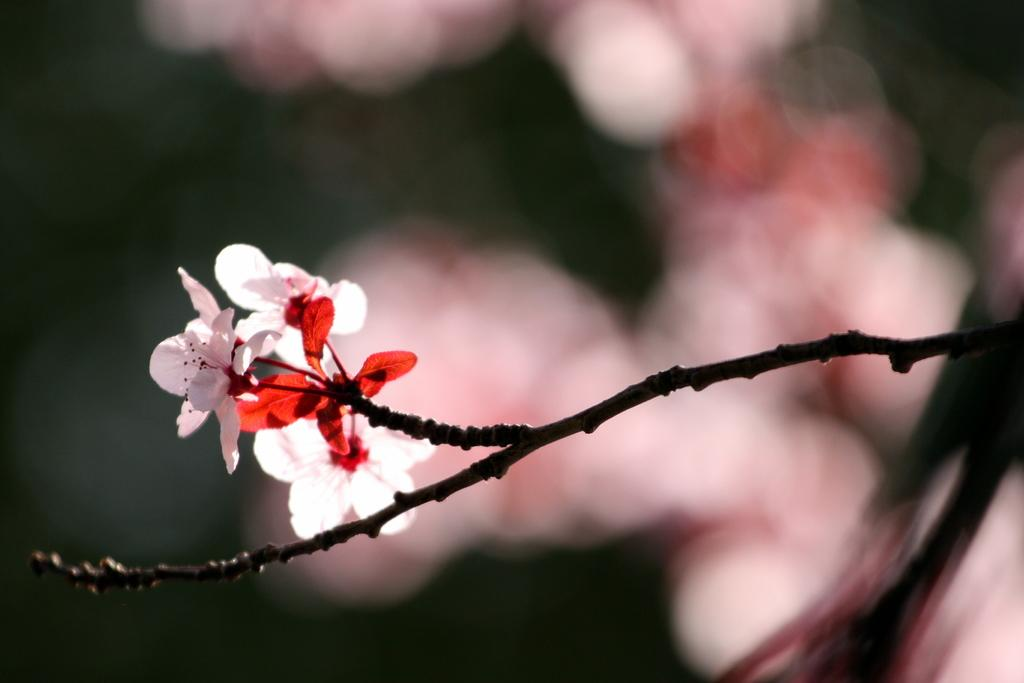What type of plant can be seen on the branch in the image? There are flowers on the branch of a tree in the image. How many weeks does the faucet in the image need to be turned on to water the flowers? There is no faucet present in the image, so it is not possible to determine how many weeks it would need to be turned on to water the flowers. 